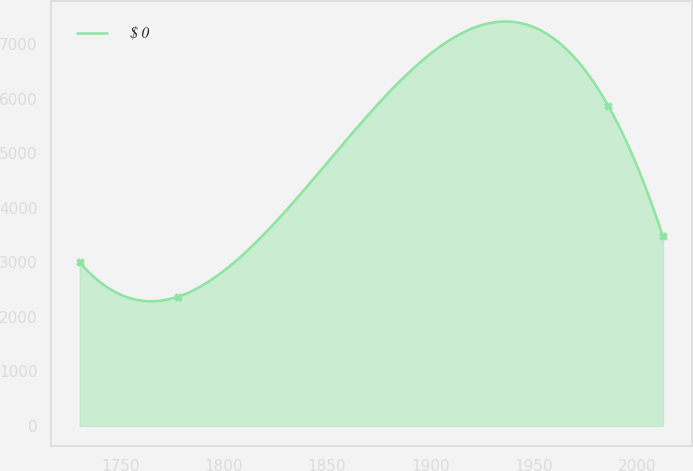Convert chart to OTSL. <chart><loc_0><loc_0><loc_500><loc_500><line_chart><ecel><fcel>$ 0<nl><fcel>1730.25<fcel>2997.33<nl><fcel>1777.76<fcel>2368.53<nl><fcel>1986.15<fcel>5875.56<nl><fcel>2012.69<fcel>3476.14<nl></chart> 